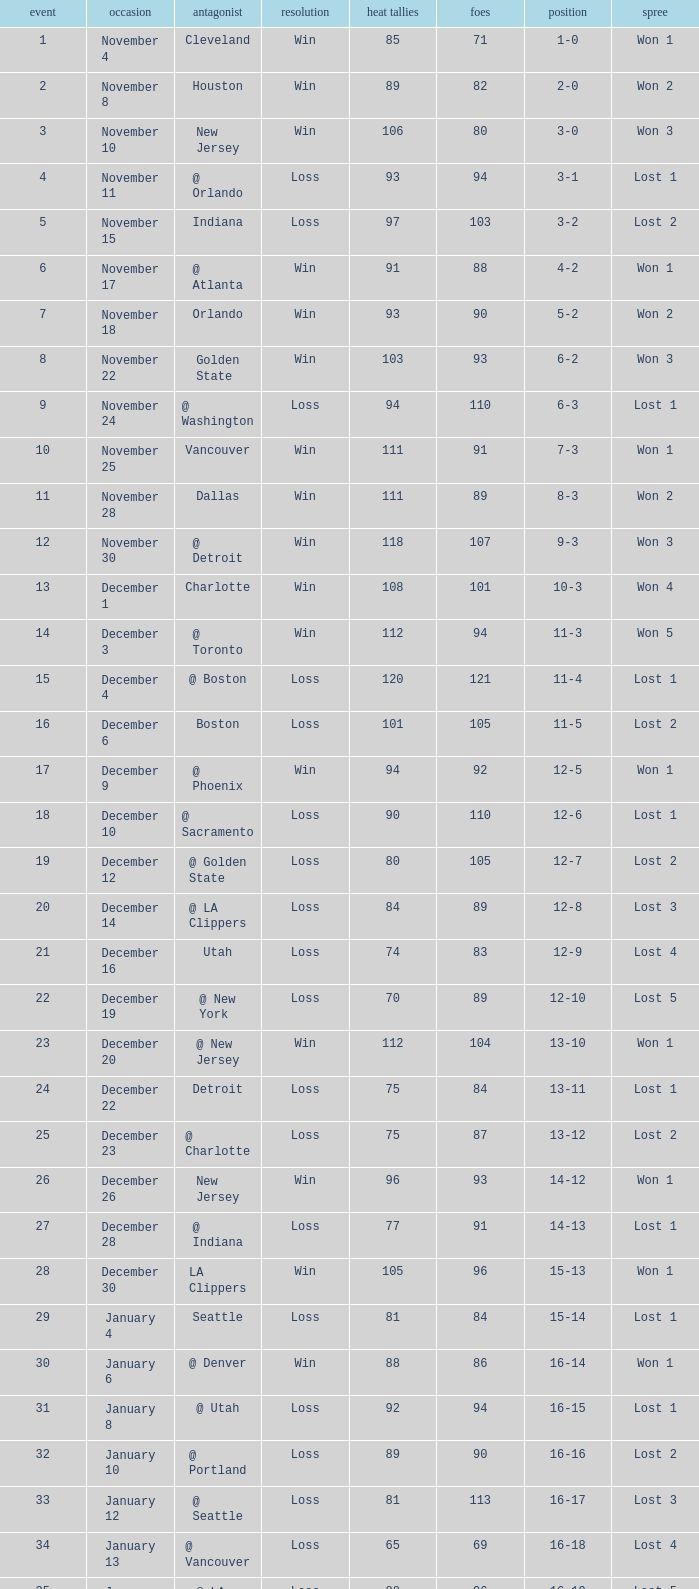What is Result, when Date is "December 12"? Loss. 